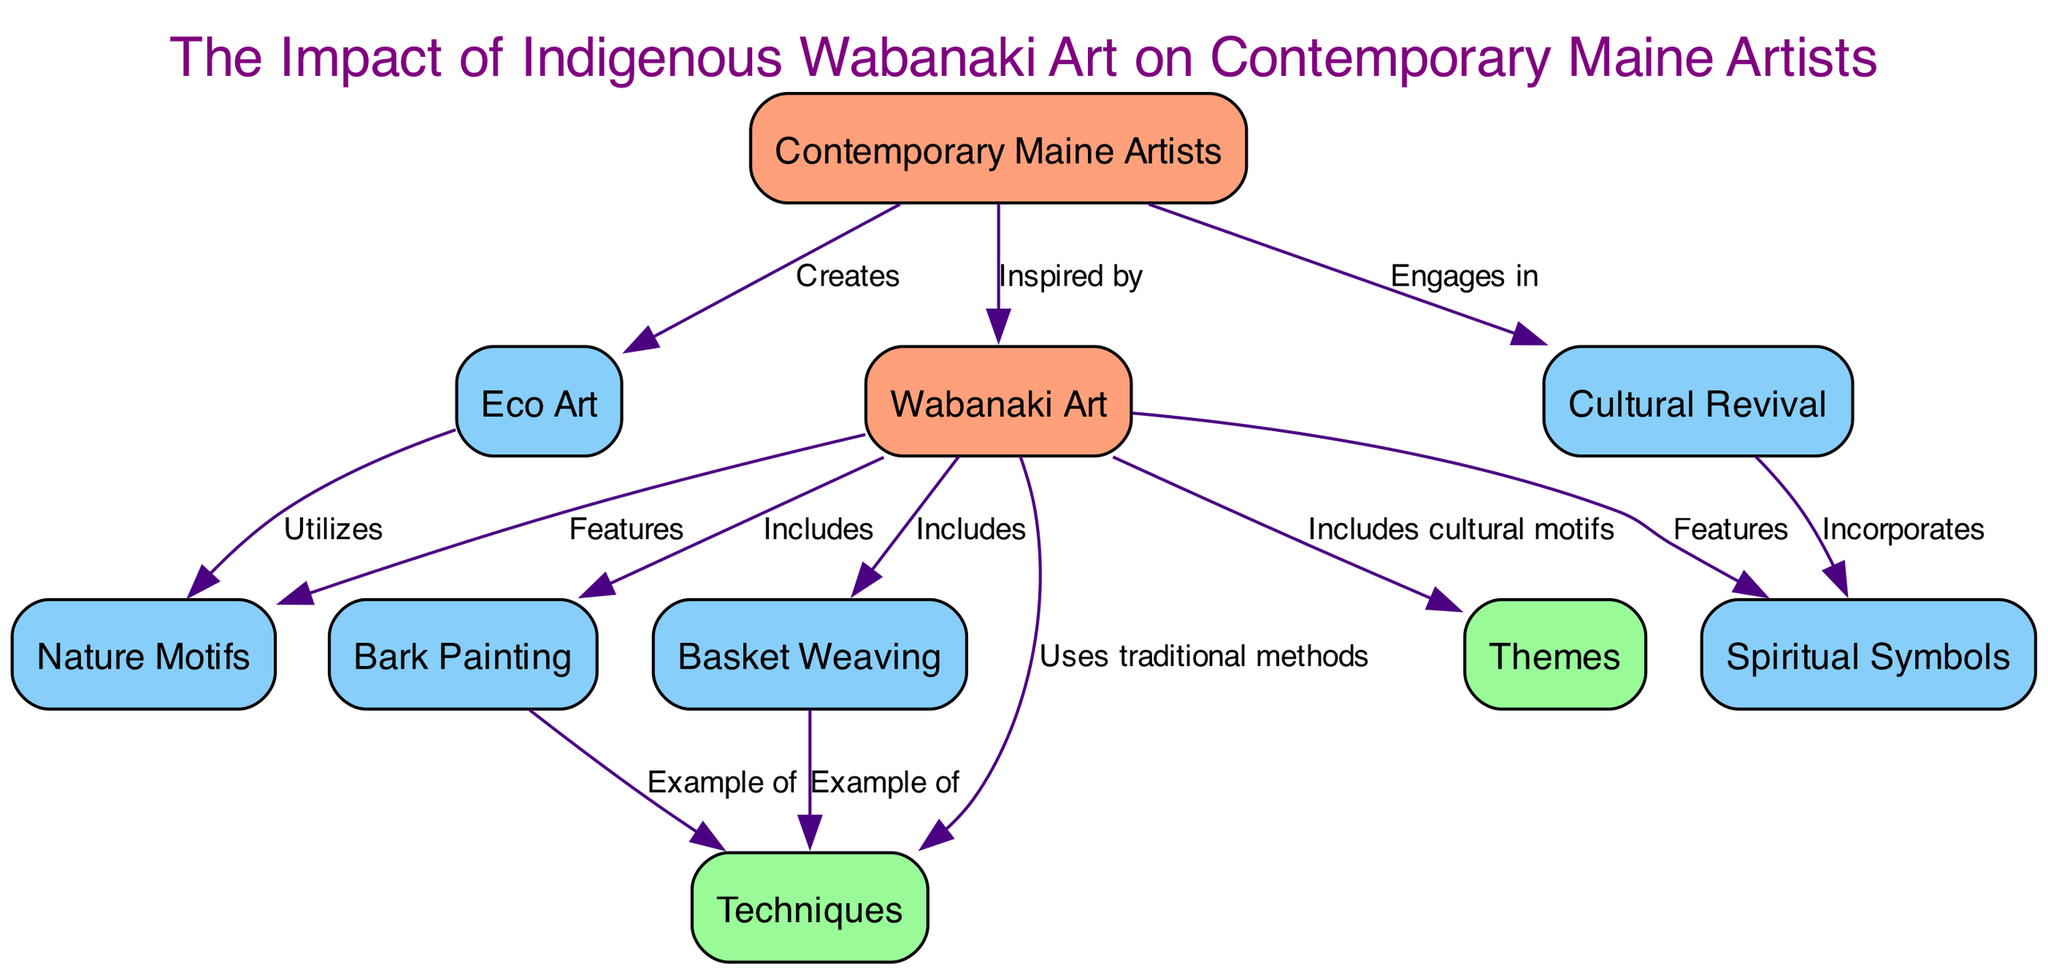What are the two main nodes in the diagram? The diagram features two main nodes: "Wabanaki Art" and "Contemporary Maine Artists," which represent traditional and modern influences respectively.
Answer: Wabanaki Art, Contemporary Maine Artists How many techniques are identified in the diagram? Counting the nodes connected to "Techniques," we find four: Bark Painting, Basket Weaving, Eco Art, and Cultural Revival.
Answer: Four Which technique is a traditional example listed in the diagram? "Bark Painting" is specifically labeled as a traditional technique used by Wabanaki artists in the diagram, serving as a classic representation of their methods.
Answer: Bark Painting What type of motifs do Contemporary Maine Artists utilize in their Eco Art? The diagram indicates that "Eco Art" makes use of "Nature Motifs," which consist of environmental themes commonly seen in both Wabanaki and contemporary works.
Answer: Nature Motifs How does "Cultural Revival" relate to "Spiritual Symbols"? According to the diagram, "Cultural Revival" incorporates "Spiritual Symbols," meaning that the efforts to revive traditional motifs in modern art include these cultural and spiritual representations.
Answer: Incorporates What label describes the relationship between "Wabanaki Art" and "Contemporary Maine Artists"? The diagram shows that "Contemporary Maine Artists" are described as being inspired by "Wabanaki Art," reflecting the influence of traditional techniques and themes on modern creators.
Answer: Inspired by Which two artistic methods are directly connected to "Techniques"? Both "Bark Painting" and "Basket Weaving" are highlighted as examples of techniques in the diagram, illustrating traditional methods of Wabanaki artists.
Answer: Bark Painting, Basket Weaving What thematic element is highlighted by both "Wabanaki Art" and "Eco Art"? The distinct thematic element shared by "Wabanaki Art" and "Eco Art" is "Nature Motifs," emphasizing the significance of environmental representations in both art forms.
Answer: Nature Motifs 